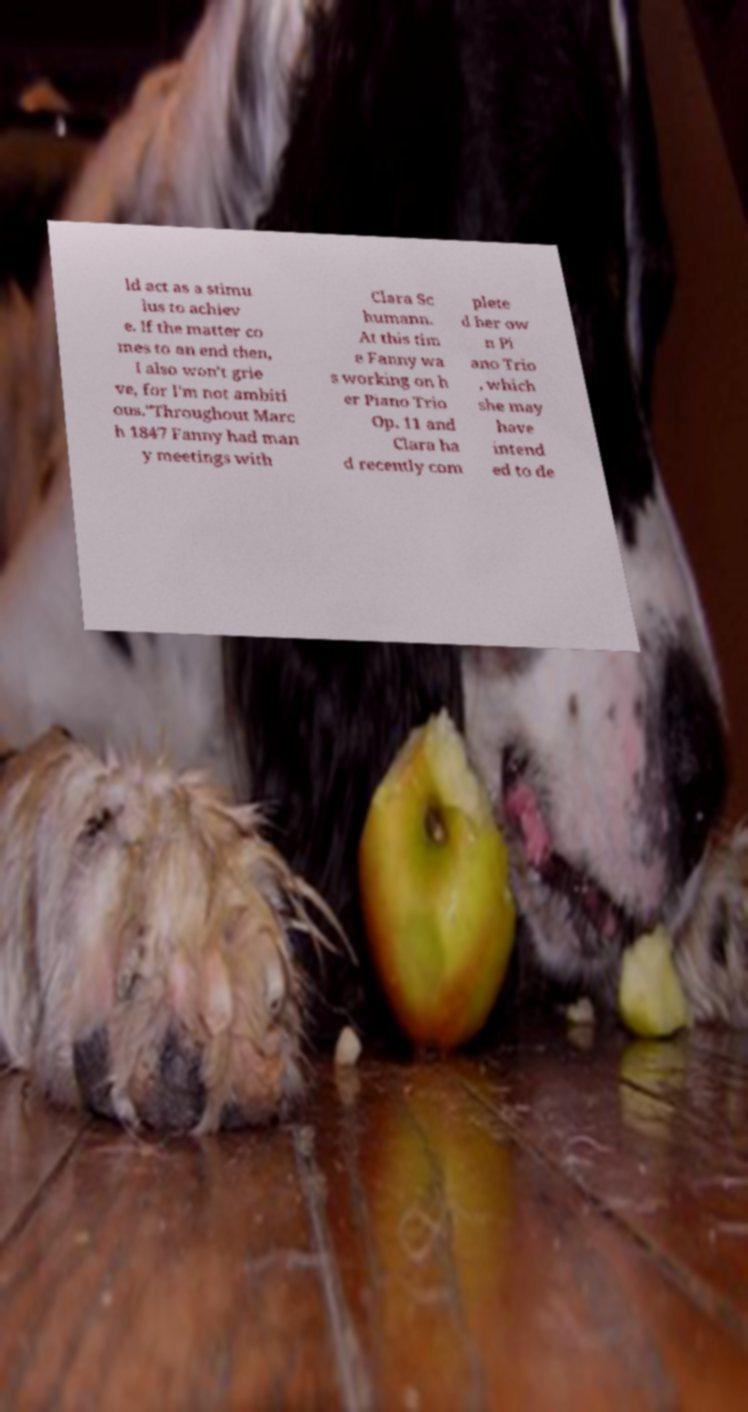Can you read and provide the text displayed in the image?This photo seems to have some interesting text. Can you extract and type it out for me? ld act as a stimu lus to achiev e. If the matter co mes to an end then, I also won't grie ve, for I'm not ambiti ous."Throughout Marc h 1847 Fanny had man y meetings with Clara Sc humann. At this tim e Fanny wa s working on h er Piano Trio Op. 11 and Clara ha d recently com plete d her ow n Pi ano Trio , which she may have intend ed to de 